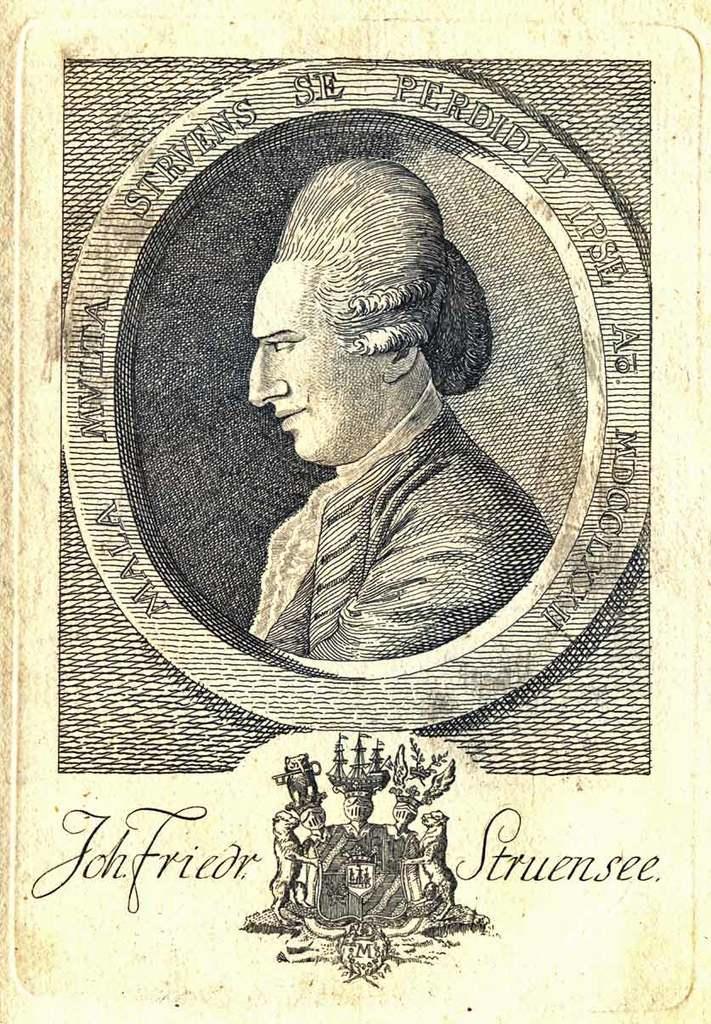In one or two sentences, can you explain what this image depicts? In this picture I can see a poster and I can see a man and I see text and looks like a logo at the bottom of the picture. 